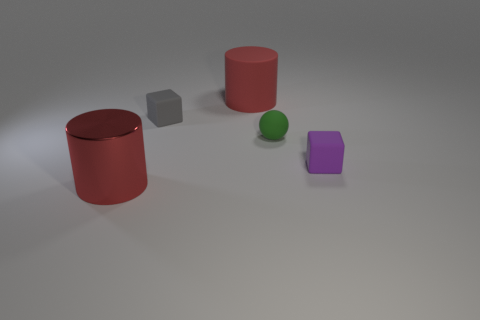Add 2 big balls. How many objects exist? 7 Subtract all blocks. How many objects are left? 3 Add 2 gray cubes. How many gray cubes exist? 3 Subtract 0 green cylinders. How many objects are left? 5 Subtract all small objects. Subtract all green rubber spheres. How many objects are left? 1 Add 1 small gray matte things. How many small gray matte things are left? 2 